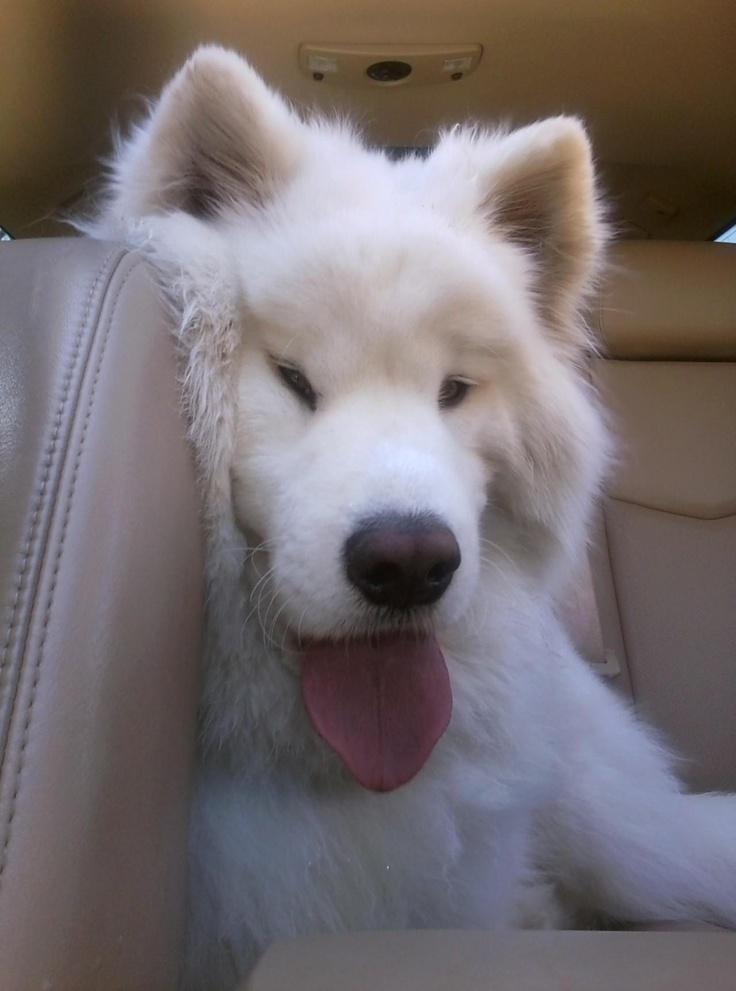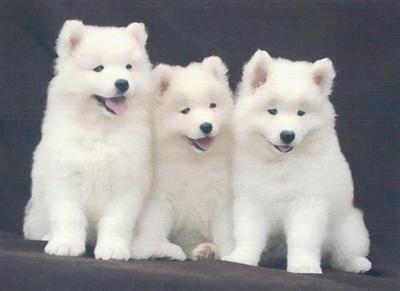The first image is the image on the left, the second image is the image on the right. For the images displayed, is the sentence "There are exactly three dogs." factually correct? Answer yes or no. No. 